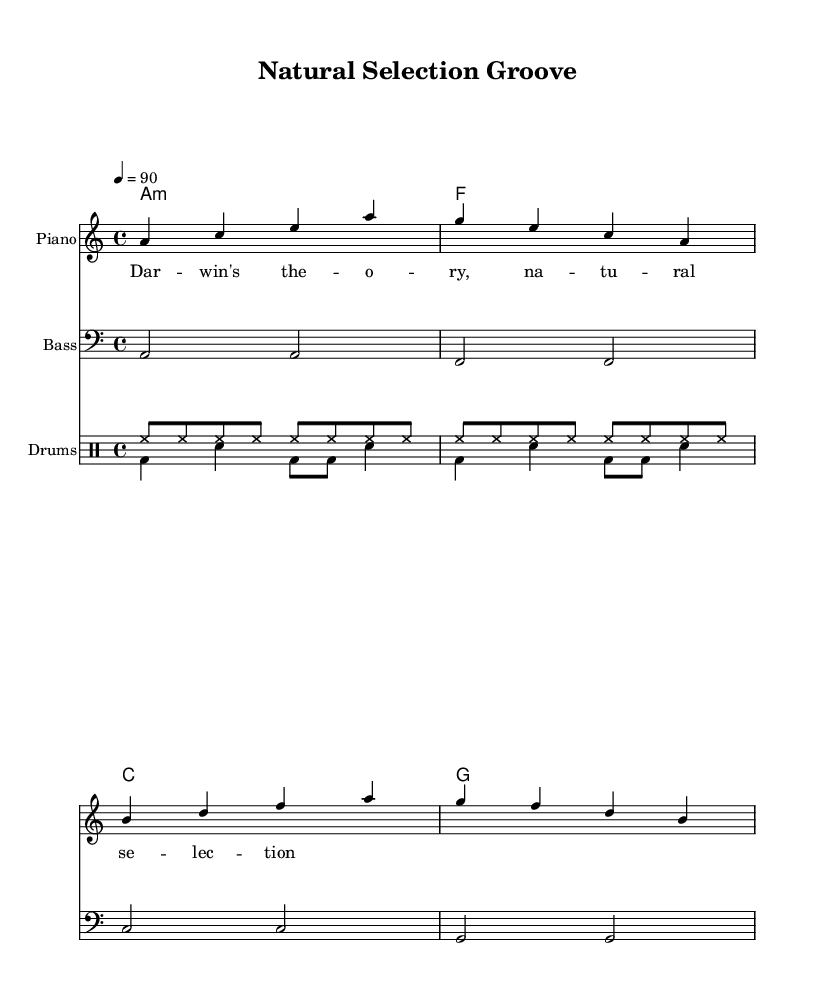What is the key signature of this music? The key signature is indicated by the 'a' at the beginning of the score, which signifies that there are no sharps or flats, making this piece in A minor.
Answer: A minor What is the time signature of this music? The time signature is shown next to the key signature, and it reads '4/4', meaning there are four beats in each measure and the quarter note gets one beat.
Answer: 4/4 What is the tempo of this music? The tempo is indicated by '4 = 90' at the beginning, which means the piece is played at a speed of 90 beats per minute.
Answer: 90 How many measures are in the melody? By counting the distinct groups of notes separated by vertical lines in the melody section, there are a total of four measures.
Answer: 4 What is the first note of the melody? The first note of the melody is indicated on the staff and it is 'a', as the first note in the series presented.
Answer: a What instrument is represented as "Piano" in the score? The staff with the label "Piano" represents the melodic section of the score designed for piano performance.
Answer: Piano How is the bass line notated in this music? The bass line is notated using a different clef, which is indicated by the 'clef bass' directive, showing a specific range for lower sounds.
Answer: Bass 